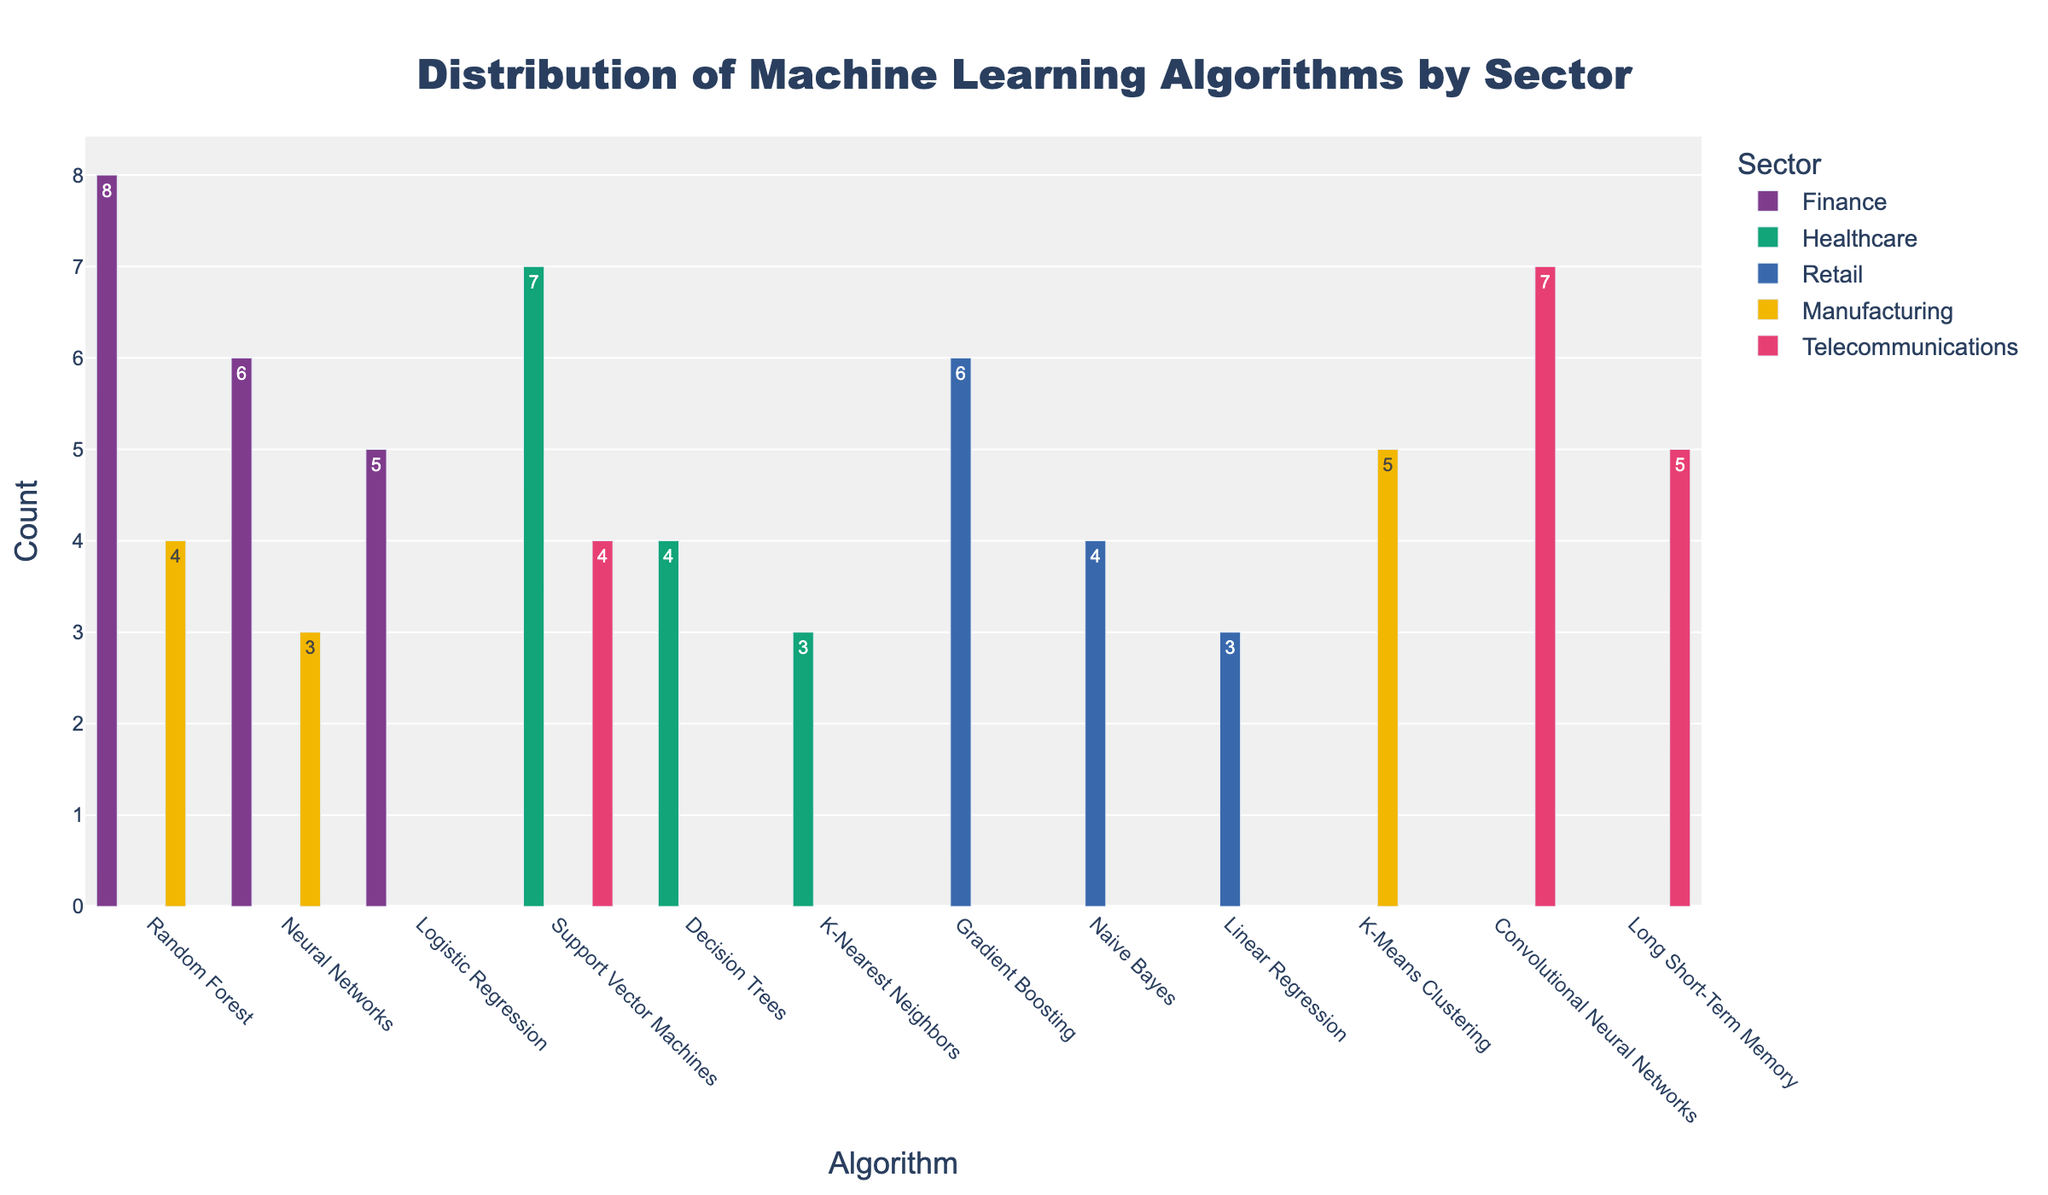What is the title of the figure? The title of the figure is prominently displayed at the top and reads 'Distribution of Machine Learning Algorithms by Sector'.
Answer: Distribution of Machine Learning Algorithms by Sector Which sector uses Random Forest the most? By looking at the height of the bars, we see the Random Forest bar for the Finance sector is the tallest among the sectors, indicating the highest count.
Answer: Finance How many sectors use Neural Networks, and what are they? Observing the labels on the x-axis and sector colors, we see Neural Networks are used in both Finance and Manufacturing. Hence, two sectors use Neural Networks.
Answer: Two sectors: Finance and Manufacturing How many algorithms are used in Finance? The bars for the Finance sector represent different algorithms used in that sector. Counting these bars gives us three: Random Forest, Neural Networks, and Logistic Regression.
Answer: 3 Which algorithm has the highest count in the Telecommunications sector? In the Telecommunications sector, the bar for Convolutional Neural Networks is the highest among others: Long Short-Term Memory and Support Vector Machines.
Answer: Convolutional Neural Networks What is the total count of algorithms used in the Retail sector? The counts for all algorithms in Retail (Gradient Boosting, Naive Bayes, Linear Regression) are 6, 4, and 3 respectively. Summing these gives 6 + 4 + 3 = 13.
Answer: 13 Compare the usage of Support Vector Machines in Healthcare and Telecommunications. Which sector has a higher count? Both sectors use Support Vector Machines. The bar for Healthcare is higher (7) than that for Telecommunications (4). Thus, Healthcare has a higher count.
Answer: Healthcare What is the average count of algorithms used in the Manufacturing sector? In Manufacturing, the counts for K-Means Clustering, Random Forest, and Neural Networks are 5, 4, and 3 respectively. Averaging these gives (5 + 4 + 3) / 3 = 12 / 3 = 4.
Answer: 4 How many sectors use Decision Trees, and what is the count for Healthcare? Decision Trees appear only once in the Healthcare sector. The count for Healthcare is indicated directly by the bar height, which is 4.
Answer: One sector: Healthcare, count: 4 What's the difference in usage count of Convolutional Neural Networks and Long Short-Term Memory in Telecommunications? The counts are 7 for Convolutional Neural Networks and 5 for Long Short-Term Memory. The difference is 7 - 5 = 2.
Answer: 2 